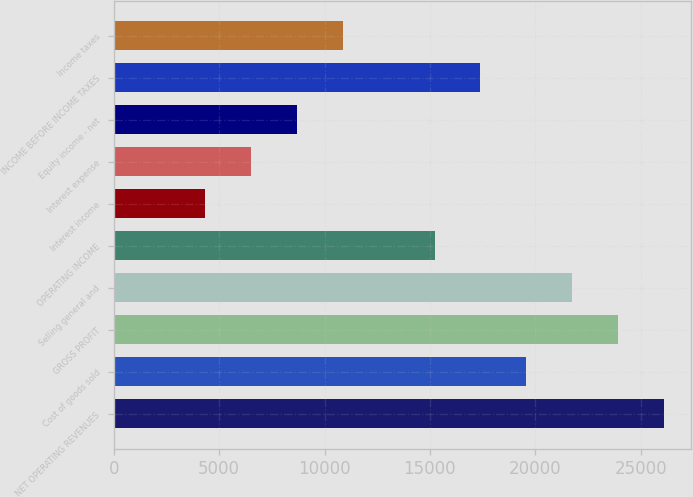Convert chart to OTSL. <chart><loc_0><loc_0><loc_500><loc_500><bar_chart><fcel>NET OPERATING REVENUES<fcel>Cost of goods sold<fcel>GROSS PROFIT<fcel>Selling general and<fcel>OPERATING INCOME<fcel>Interest income<fcel>Interest expense<fcel>Equity income - net<fcel>INCOME BEFORE INCOME TAXES<fcel>Income taxes<nl><fcel>26090<fcel>19568<fcel>23916<fcel>21742<fcel>15220<fcel>4350<fcel>6524<fcel>8698<fcel>17394<fcel>10872<nl></chart> 